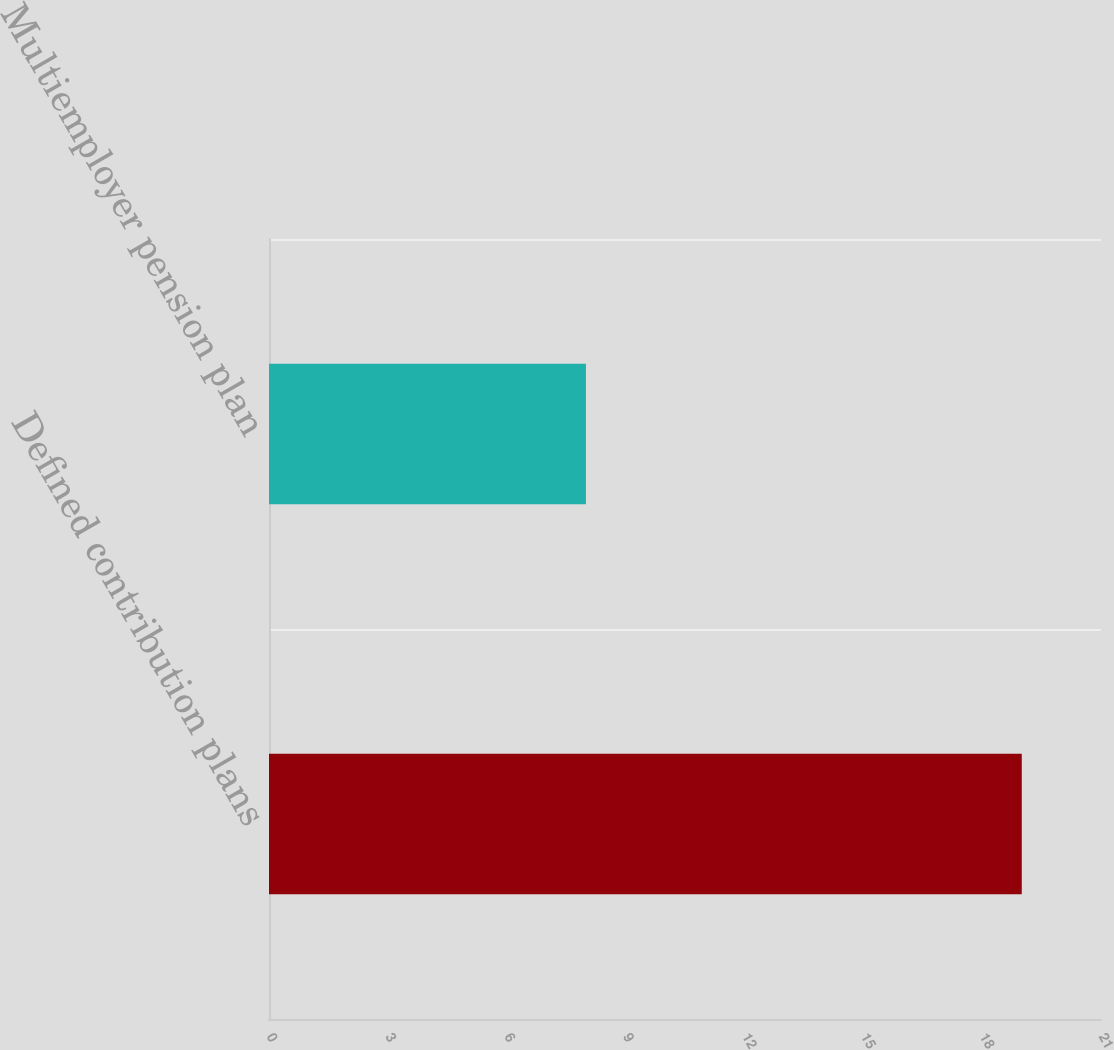<chart> <loc_0><loc_0><loc_500><loc_500><bar_chart><fcel>Defined contribution plans<fcel>Multiemployer pension plan<nl><fcel>19<fcel>8<nl></chart> 